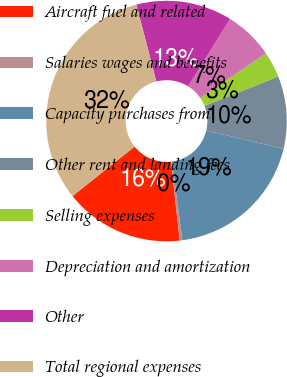Convert chart. <chart><loc_0><loc_0><loc_500><loc_500><pie_chart><fcel>Aircraft fuel and related<fcel>Salaries wages and benefits<fcel>Capacity purchases from<fcel>Other rent and landing fees<fcel>Selling expenses<fcel>Depreciation and amortization<fcel>Other<fcel>Total regional expenses<nl><fcel>16.03%<fcel>0.36%<fcel>19.16%<fcel>9.76%<fcel>3.49%<fcel>6.62%<fcel>12.89%<fcel>31.69%<nl></chart> 